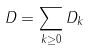<formula> <loc_0><loc_0><loc_500><loc_500>D = \sum _ { k \geq 0 } D _ { k }</formula> 